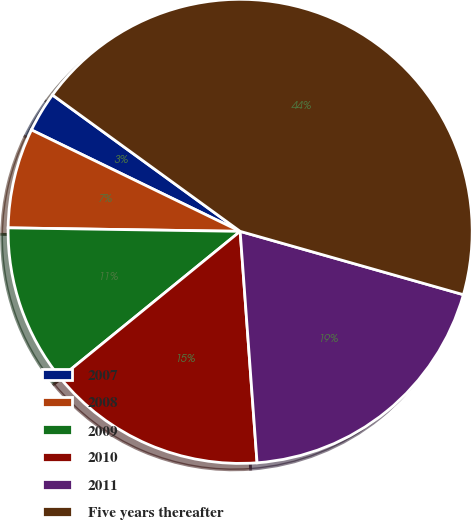<chart> <loc_0><loc_0><loc_500><loc_500><pie_chart><fcel>2007<fcel>2008<fcel>2009<fcel>2010<fcel>2011<fcel>Five years thereafter<nl><fcel>2.8%<fcel>6.96%<fcel>11.12%<fcel>15.28%<fcel>19.44%<fcel>44.4%<nl></chart> 